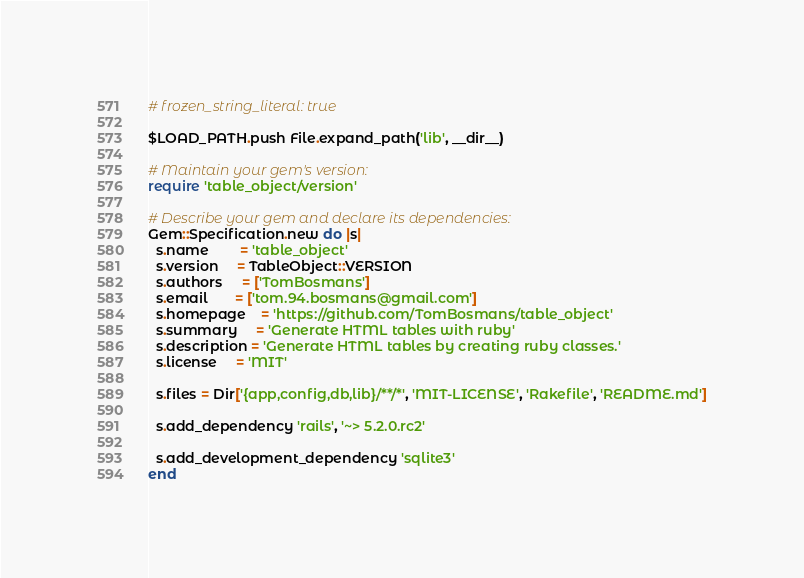Convert code to text. <code><loc_0><loc_0><loc_500><loc_500><_Ruby_># frozen_string_literal: true

$LOAD_PATH.push File.expand_path('lib', __dir__)

# Maintain your gem's version:
require 'table_object/version'

# Describe your gem and declare its dependencies:
Gem::Specification.new do |s|
  s.name        = 'table_object'
  s.version     = TableObject::VERSION
  s.authors     = ['TomBosmans']
  s.email       = ['tom.94.bosmans@gmail.com']
  s.homepage    = 'https://github.com/TomBosmans/table_object'
  s.summary     = 'Generate HTML tables with ruby'
  s.description = 'Generate HTML tables by creating ruby classes.'
  s.license     = 'MIT'

  s.files = Dir['{app,config,db,lib}/**/*', 'MIT-LICENSE', 'Rakefile', 'README.md']

  s.add_dependency 'rails', '~> 5.2.0.rc2'

  s.add_development_dependency 'sqlite3'
end
</code> 